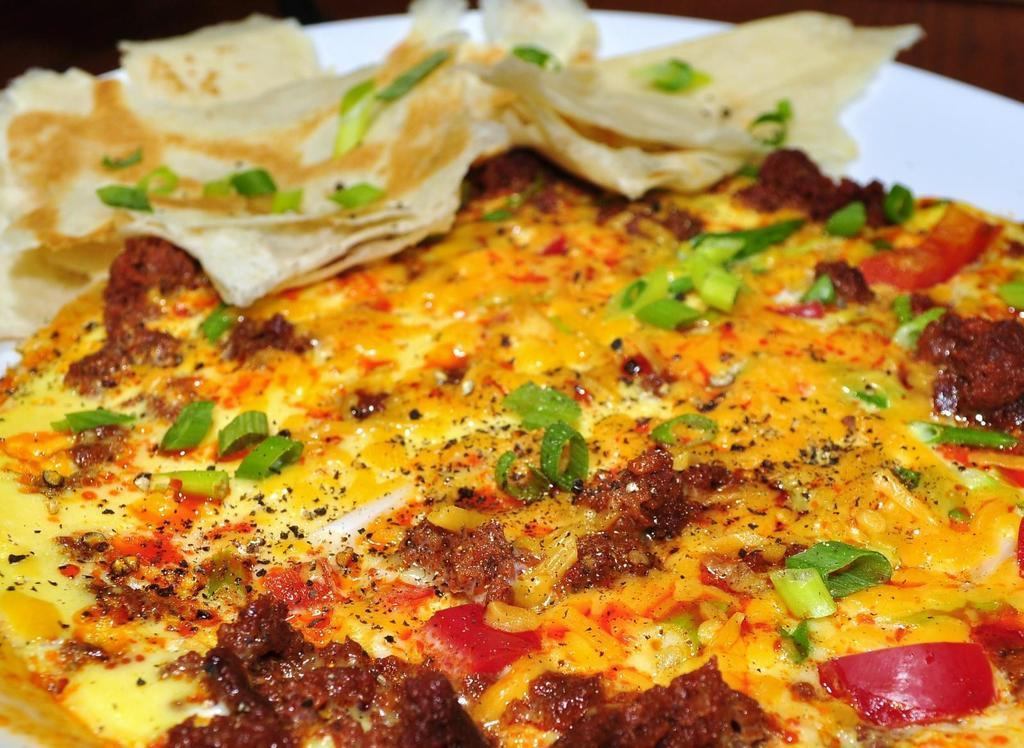What is the main subject of the image? There is a food item in the image. How is the food item presented in the image? The food item is in a plate. What type of tax is being discussed in the image? There is no discussion of tax in the image; it features a food item in a plate. How many competitors are participating in the competition in the image? There is no competition present in the image; it features a food item in a plate. 